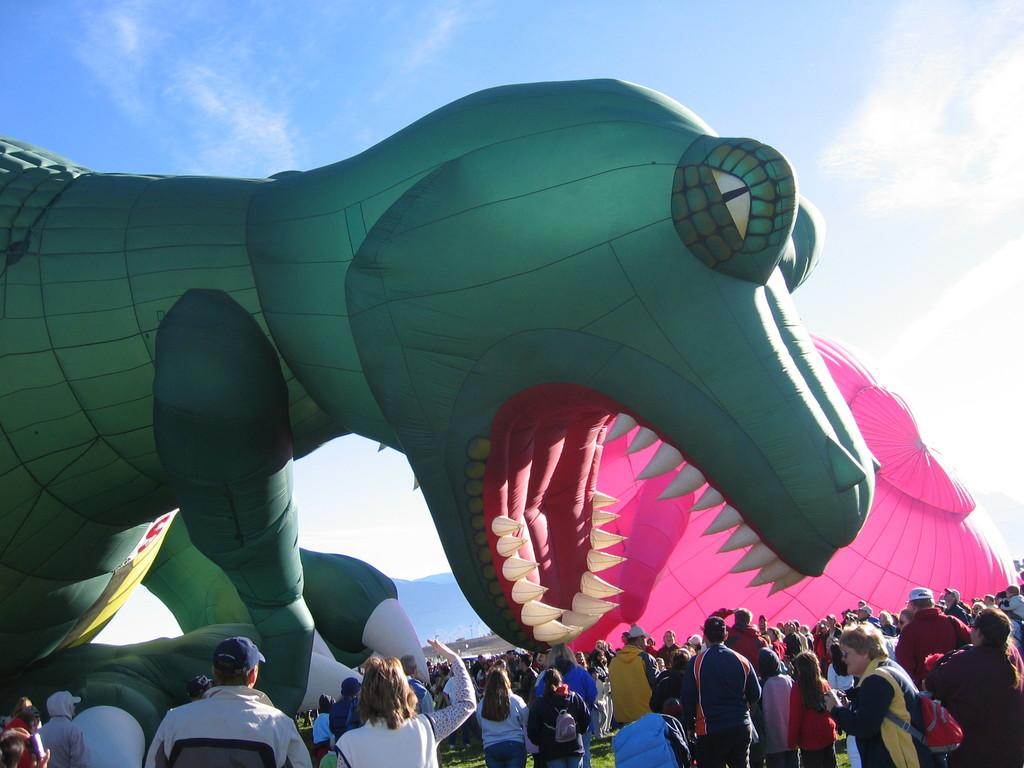What is the main subject in the center of the image? There are balloons in the center of the image. Who or what is located at the bottom of the image? There are people at the bottom of the image. What can be seen at the top of the image? The sky is visible at the top of the image. How many fairies are holding the balloons in the image? There are no fairies present in the image; it features balloons and people. What type of debt is being discussed in the image? There is no mention of debt in the image; it focuses on balloons and people. 